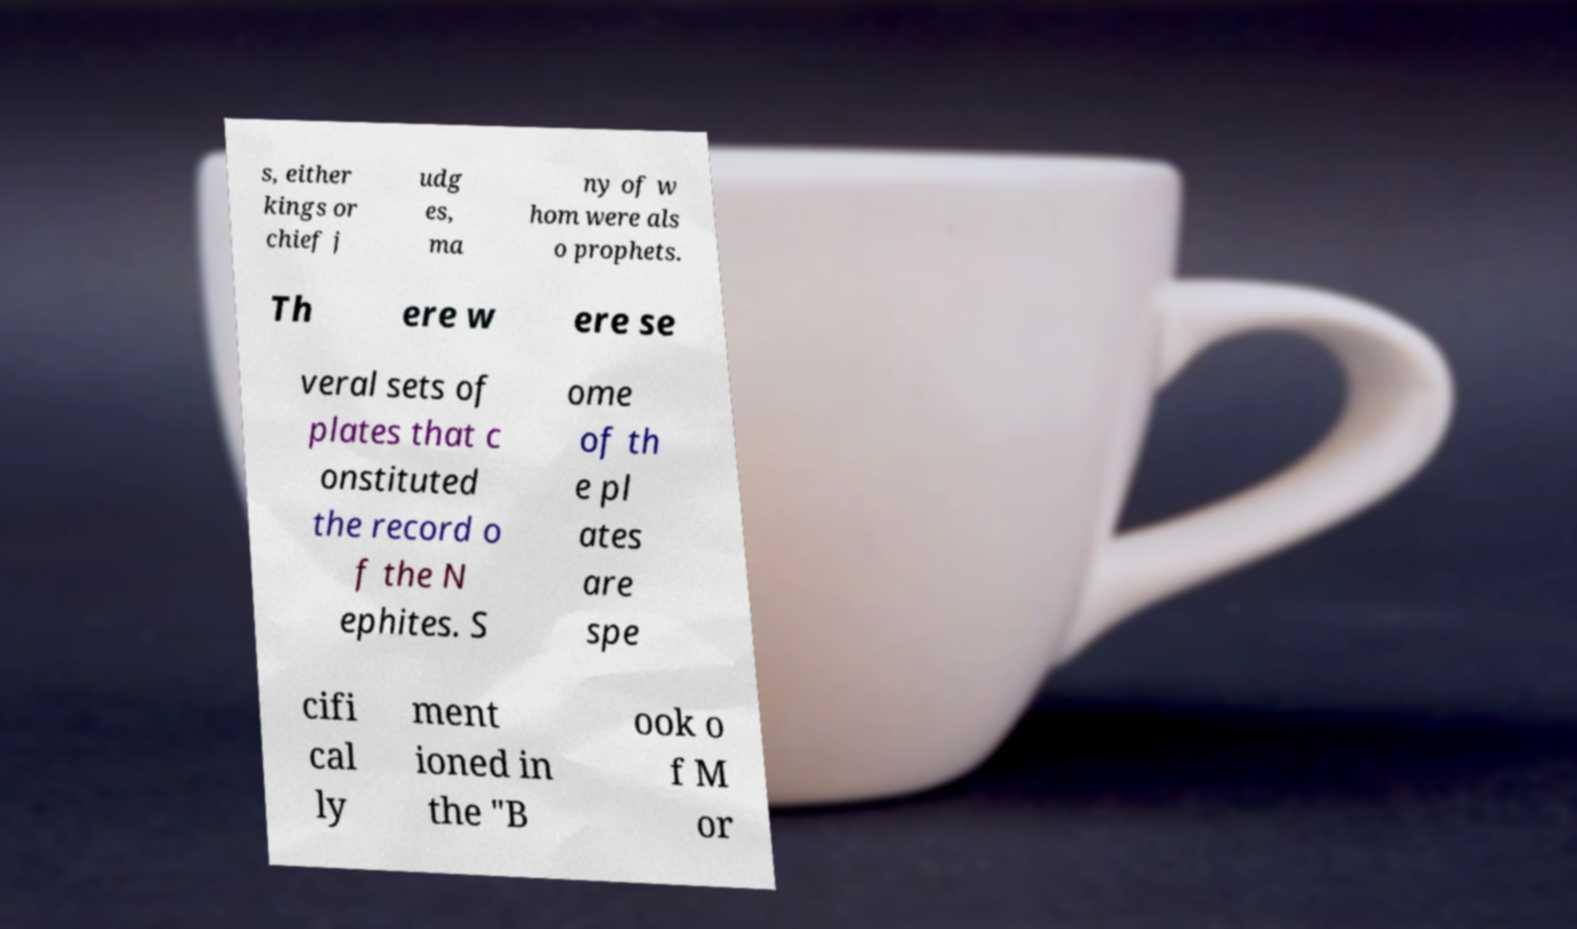For documentation purposes, I need the text within this image transcribed. Could you provide that? s, either kings or chief j udg es, ma ny of w hom were als o prophets. Th ere w ere se veral sets of plates that c onstituted the record o f the N ephites. S ome of th e pl ates are spe cifi cal ly ment ioned in the "B ook o f M or 